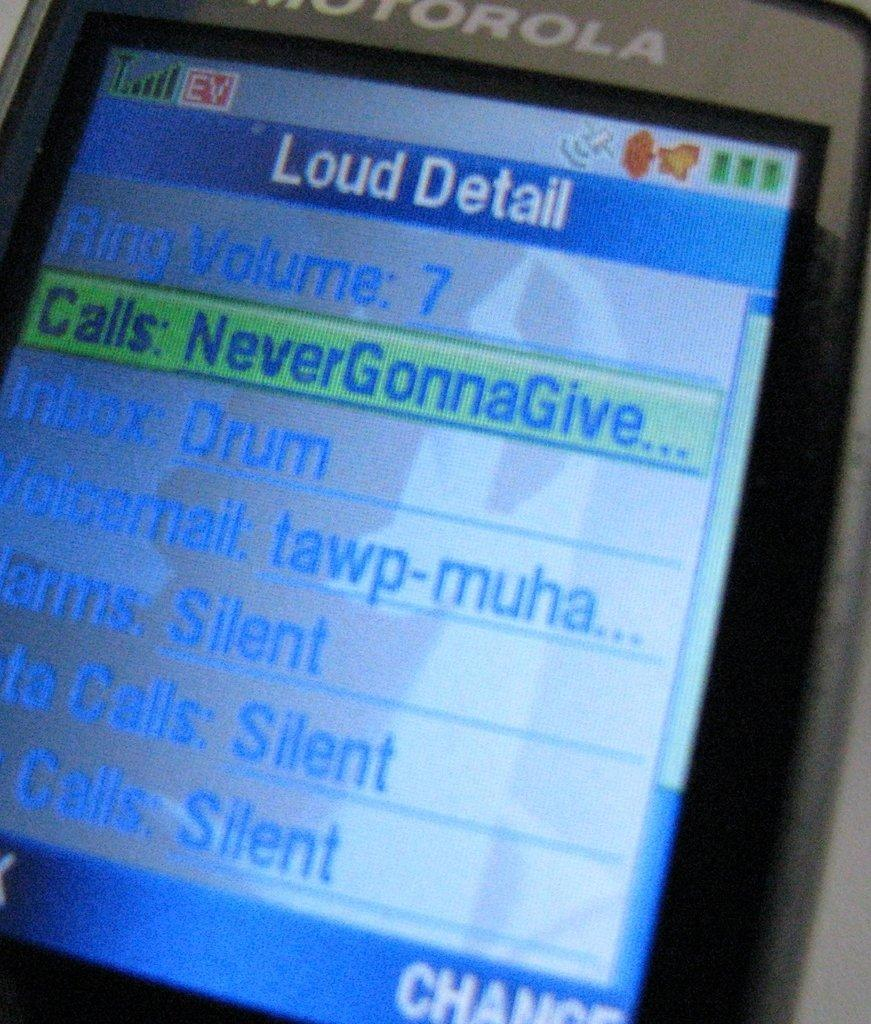<image>
Write a terse but informative summary of the picture. a silver motorola phone open to a page titled 'loud detail' 